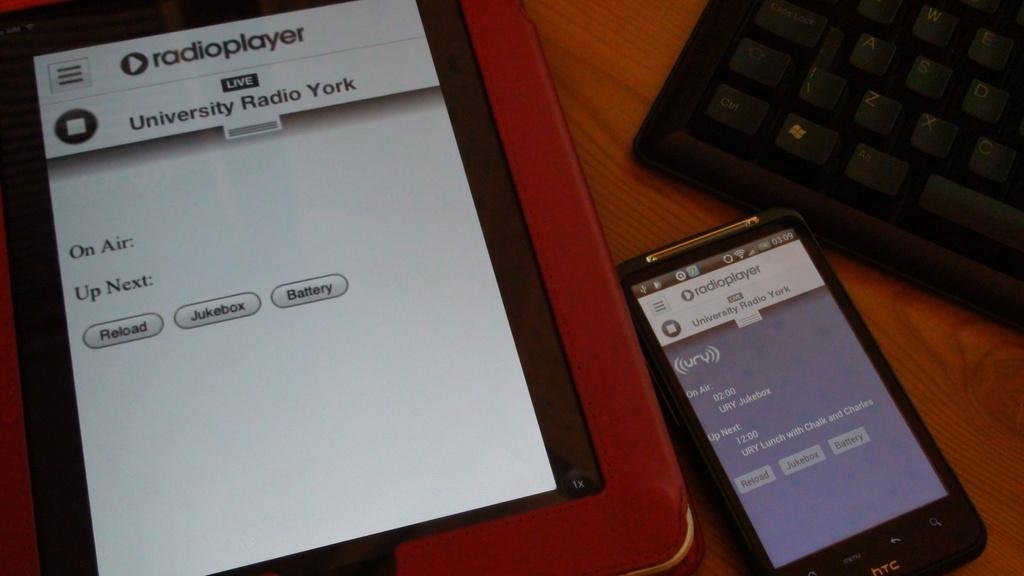<image>
Write a terse but informative summary of the picture. An HTC cellphone displaying the radioplayer app next to another electronic displaying the same app 